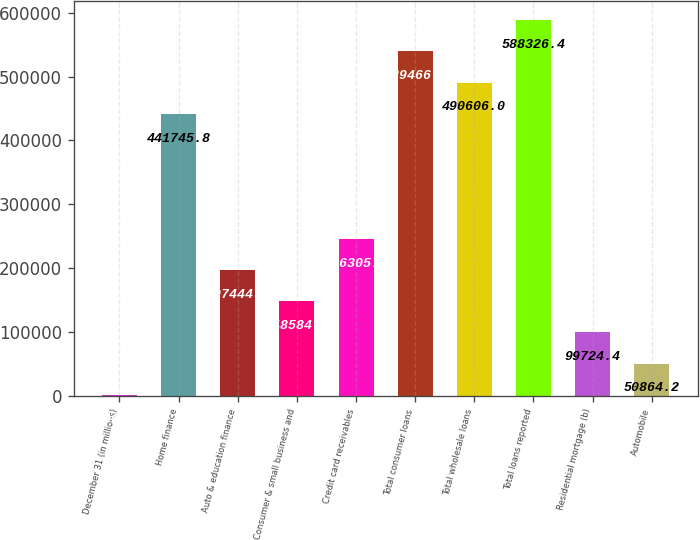Convert chart. <chart><loc_0><loc_0><loc_500><loc_500><bar_chart><fcel>December 31 (in millions)<fcel>Home finance<fcel>Auto & education finance<fcel>Consumer & small business and<fcel>Credit card receivables<fcel>Total consumer loans<fcel>Total wholesale loans<fcel>Total loans reported<fcel>Residential mortgage (b)<fcel>Automobile<nl><fcel>2004<fcel>441746<fcel>197445<fcel>148585<fcel>246305<fcel>539466<fcel>490606<fcel>588326<fcel>99724.4<fcel>50864.2<nl></chart> 